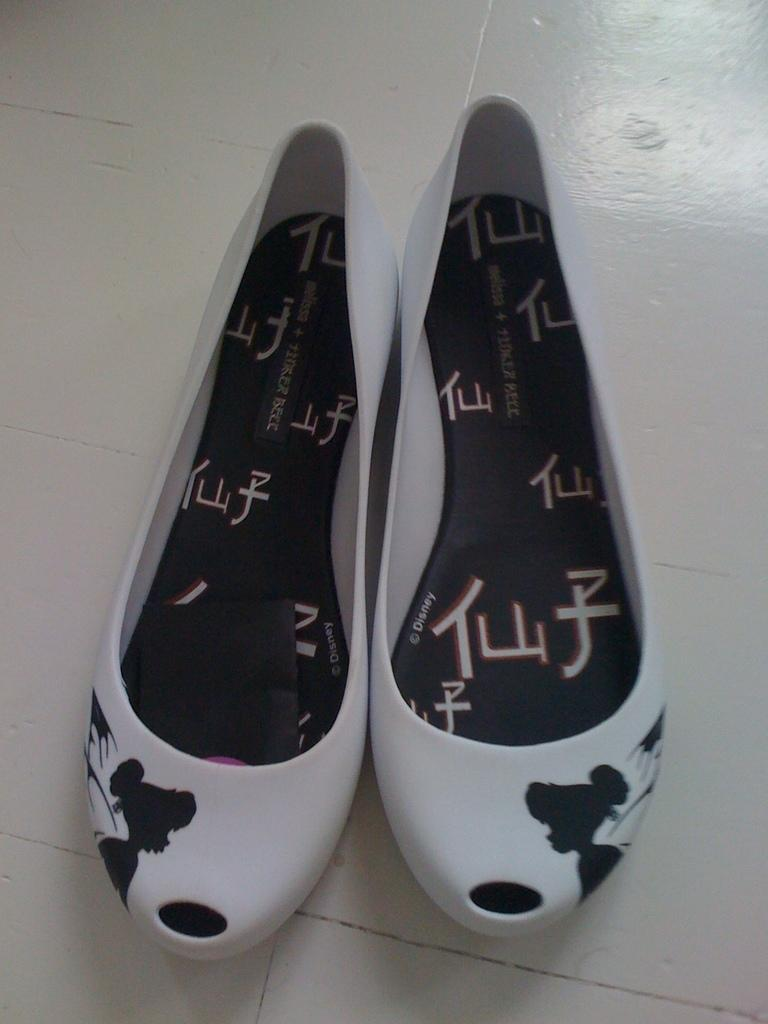What type of footwear is visible in the image? There is a pair of white shoes in the image. Where are the shoes located? The shoes are on the floor. What type of destruction is caused by the boy in the image? There is no boy present in the image, and therefore no destruction can be observed. 